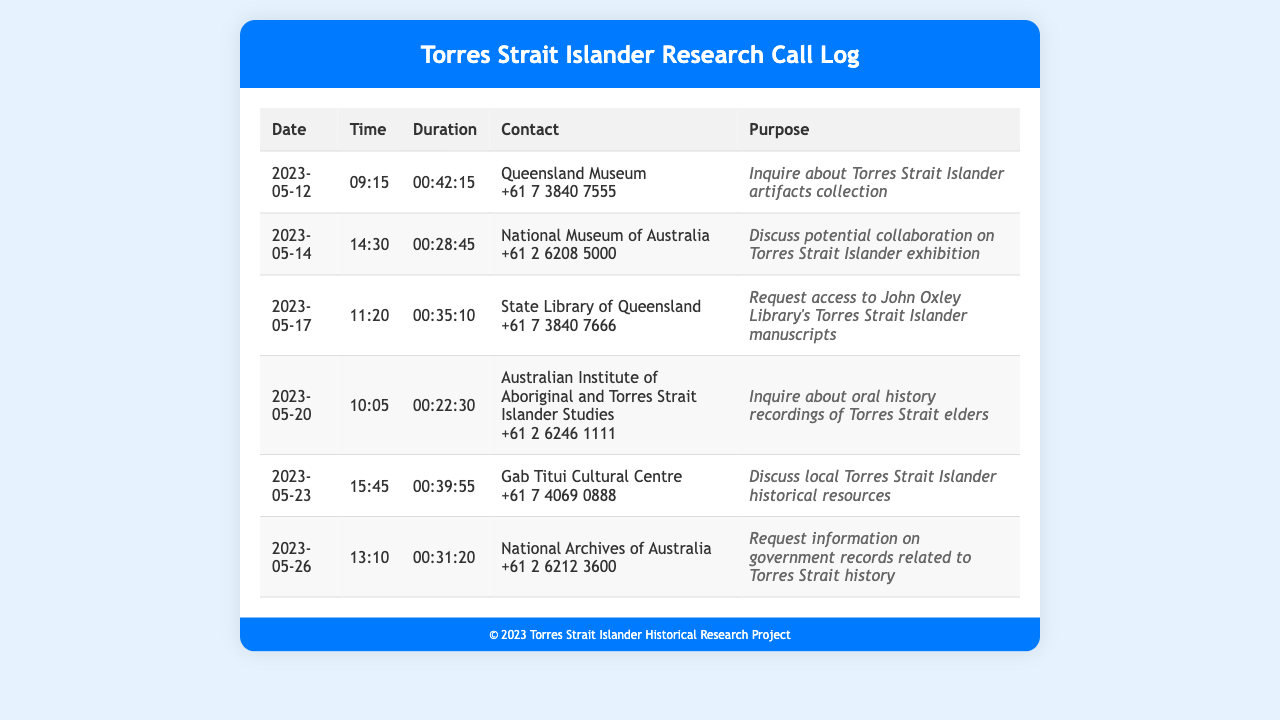What was the date of the call to the Queensland Museum? The date of the call to the Queensland Museum is listed in the document.
Answer: 2023-05-12 How long was the call to the National Museum of Australia? The document provides the duration of the call to the National Museum of Australia.
Answer: 00:28:45 What is the purpose of the call made to the Gab Titui Cultural Centre? The document includes the purpose of each call, including the one to the Gab Titui Cultural Centre.
Answer: Discuss local Torres Strait Islander historical resources Which contact was called regarding oral history recordings of Torres Strait elders? The document specifies which contact was reached out to for oral history recordings.
Answer: Australian Institute of Aboriginal and Torres Strait Islander Studies How many calls were made in total? By counting the entries in the document, the total number of calls can be determined.
Answer: 6 Which organization was contacted on 2023-05-20? The document lists the contacts alongside the dates.
Answer: Australian Institute of Aboriginal and Torres Strait Islander Studies What contact number was provided for the State Library of Queensland? The document provides the contact number for each organization, including the State Library of Queensland.
Answer: +61 7 3840 7666 What is the earliest date of the calls listed in the document? The earliest date can be found by reviewing the dates in the call log.
Answer: 2023-05-12 